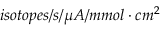<formula> <loc_0><loc_0><loc_500><loc_500>i s o t o p e s / s / \mu A / m m o l \cdot c m ^ { 2 }</formula> 